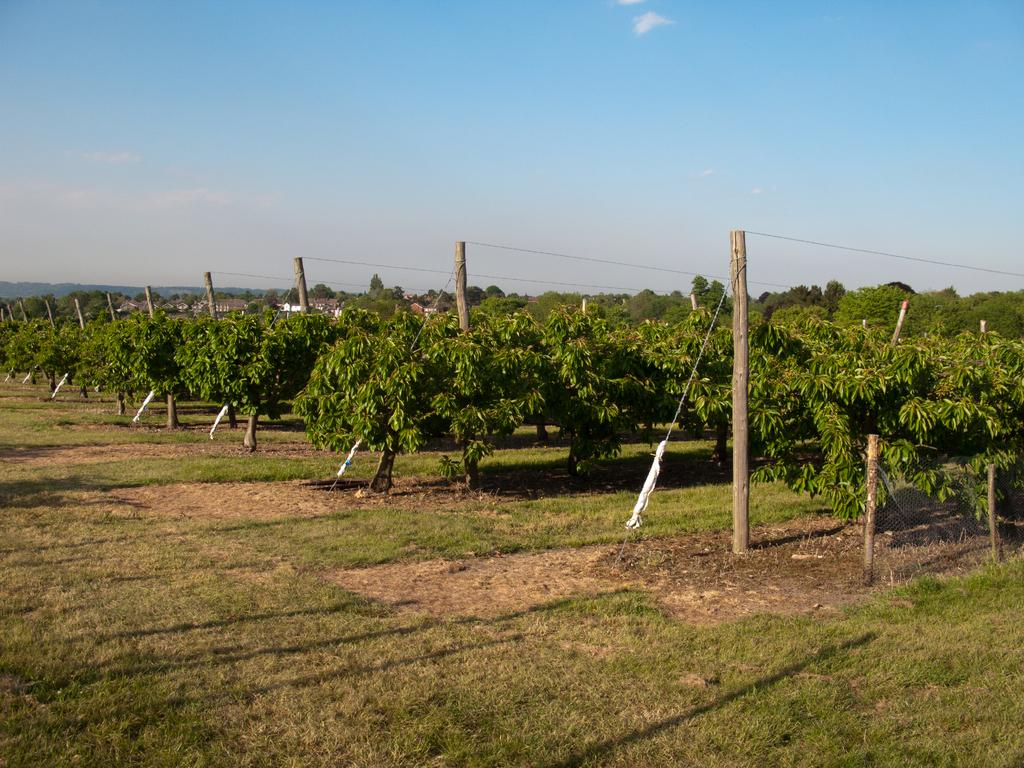What type of ground is visible in the image? There is a greenery ground in the image. What can be seen growing on the ground? There are plants in the image. What objects are placed in front of the greenery ground? There are wooden sticks in front of the greenery ground. What is visible in the background of the image? There are trees and buildings in the background of the image. What color is the pear in the image? There is no pear present in the image. What shape is the night sky in the image? The image does not depict a night sky. 